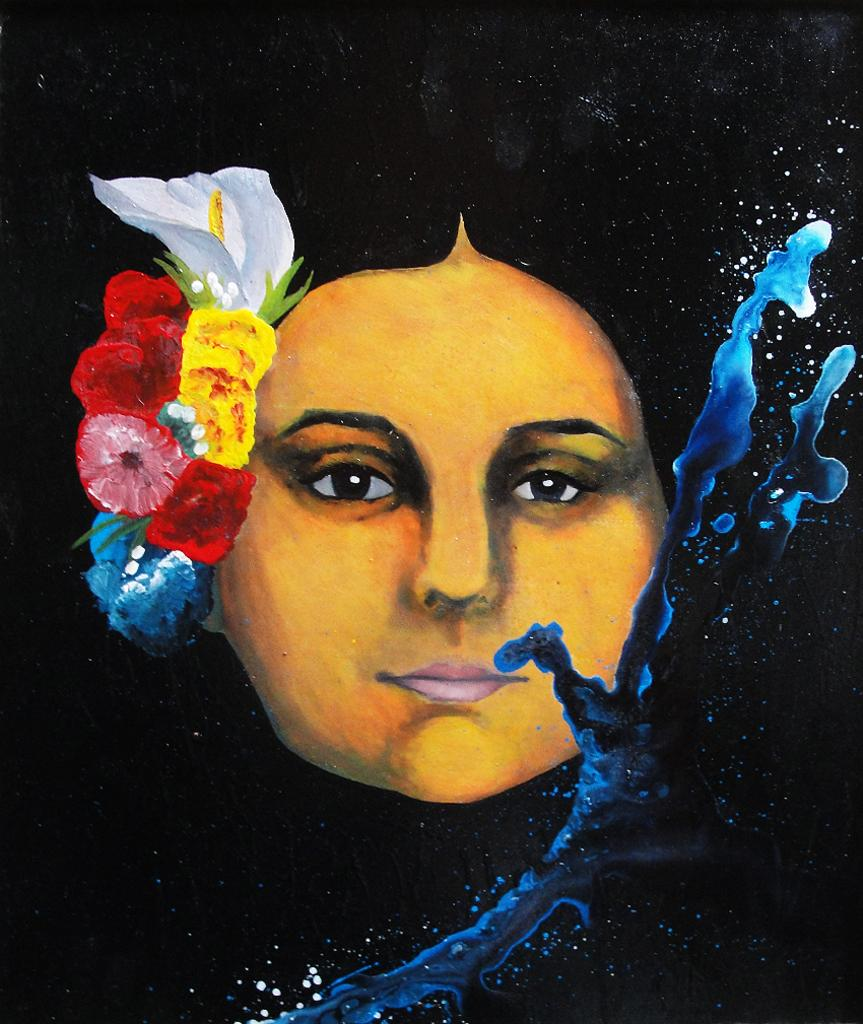What is the main subject of the image? There is a painting in the image. What is depicted in the painting? The painting depicts a woman. What color is the background of the painting? The background of the painting is black. Can you tell me how many people are laughing at the joke on the seashore in the image? There is no seashore, joke, or people laughing in the image; it features a painting of a woman with a black background. 